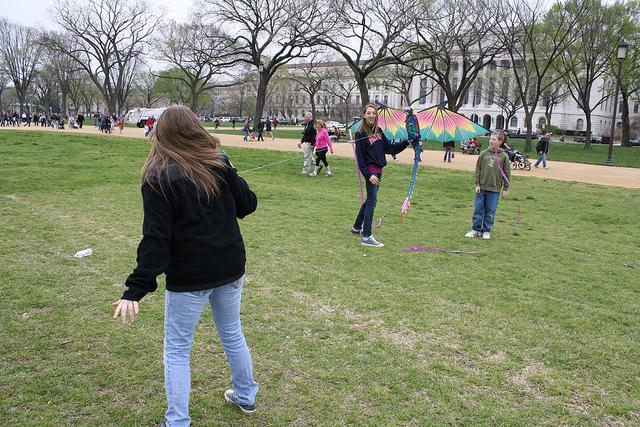What would you likely put in the thing on the ground that looks like garbage? Please explain your reasoning. water. The water is in the garbage. 